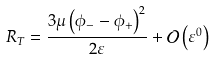<formula> <loc_0><loc_0><loc_500><loc_500>R _ { T } = \frac { { 3 \mu \left ( { \phi _ { - } - \phi _ { + } } \right ) ^ { 2 } } } { 2 \varepsilon } + \mathcal { O } \left ( { \varepsilon ^ { 0 } } \right )</formula> 